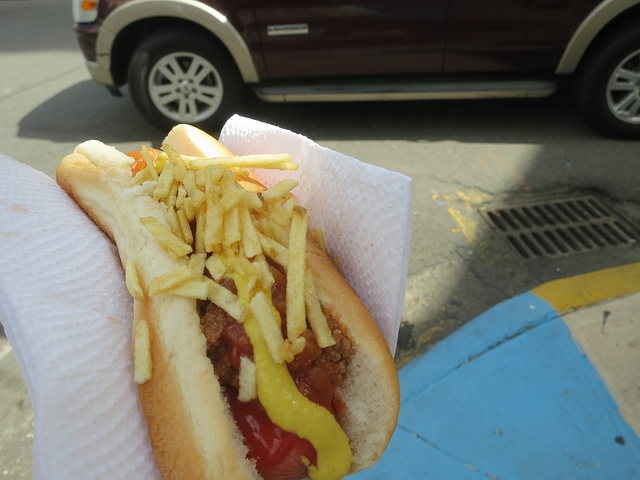Describe the objects in this image and their specific colors. I can see hot dog in gray, tan, maroon, and olive tones and car in gray, black, and darkgreen tones in this image. 